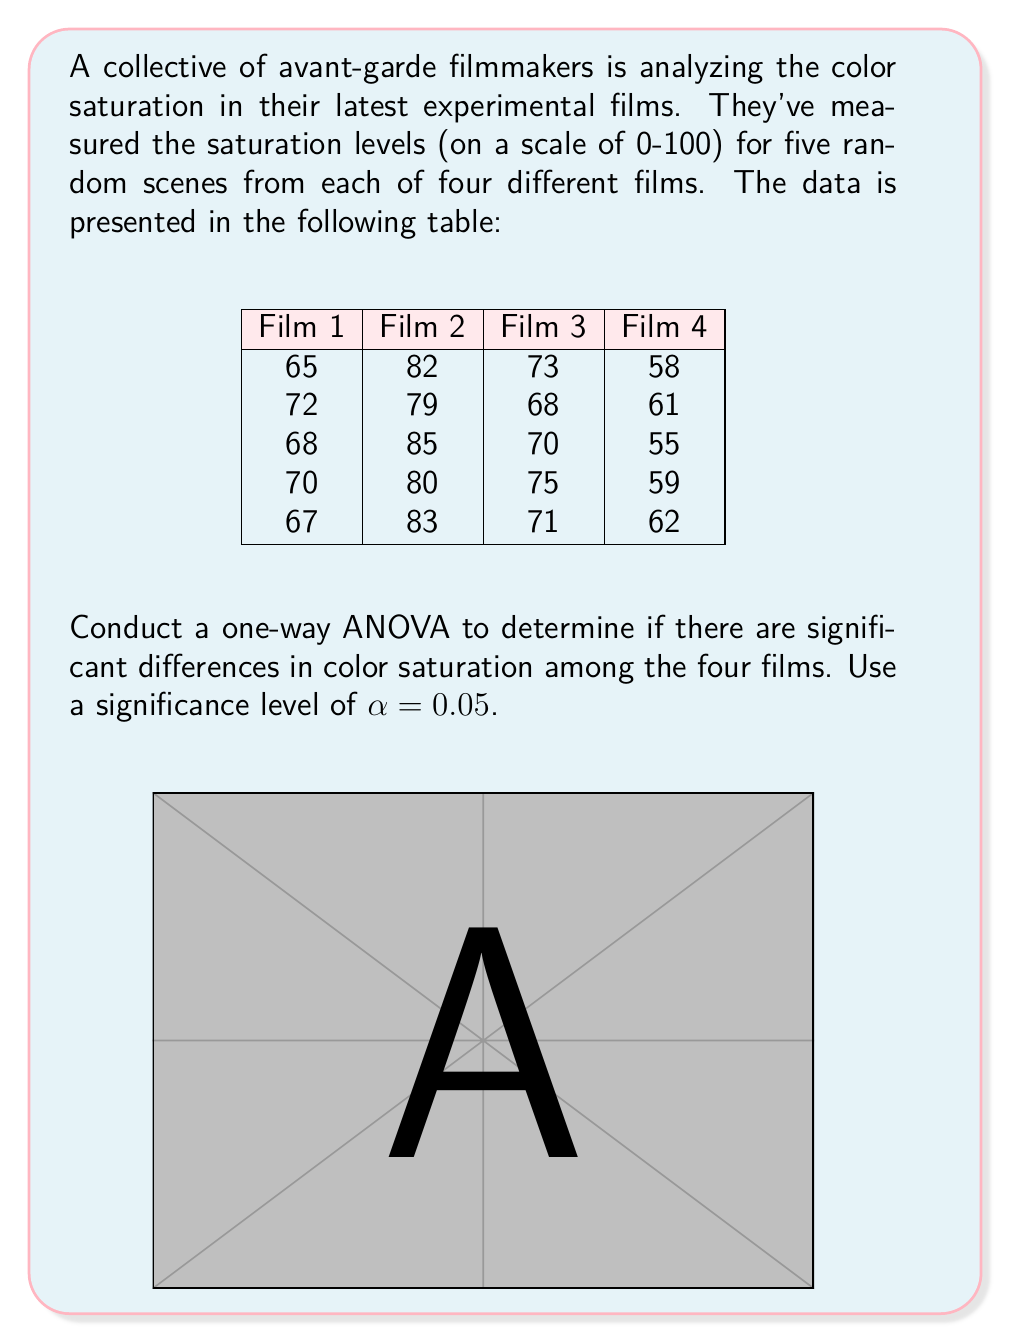Give your solution to this math problem. Let's conduct a one-way ANOVA step by step:

1) First, we need to calculate the following:
   - Grand mean
   - Sum of squares total (SST)
   - Sum of squares between groups (SSB)
   - Sum of squares within groups (SSW)
   - Degrees of freedom
   - Mean square between groups (MSB)
   - Mean square within groups (MSW)
   - F-statistic

2) Calculate the grand mean:
   $\bar{X} = \frac{65+72+68+70+67+82+79+85+80+83+73+68+70+75+71+58+61+55+59+62}{20} = 71.15$

3) Calculate SST:
   $SST = \sum_{i=1}^{4}\sum_{j=1}^{5} (X_{ij} - \bar{X})^2 = 1842.55$

4) Calculate SSB:
   $SSB = 5[(68.4-71.15)^2 + (81.8-71.15)^2 + (71.4-71.15)^2 + (59-71.15)^2] = 1537.55$

5) Calculate SSW:
   $SSW = SST - SSB = 1842.55 - 1537.55 = 305$

6) Degrees of freedom:
   - Between groups: $df_B = 4 - 1 = 3$
   - Within groups: $df_W = 20 - 4 = 16$
   - Total: $df_T = 20 - 1 = 19$

7) Calculate MSB and MSW:
   $MSB = \frac{SSB}{df_B} = \frac{1537.55}{3} = 512.52$
   $MSW = \frac{SSW}{df_W} = \frac{305}{16} = 19.06$

8) Calculate F-statistic:
   $F = \frac{MSB}{MSW} = \frac{512.52}{19.06} = 26.89$

9) Find the critical F-value:
   For α = 0.05, df_B = 3, and df_W = 16, the critical F-value is approximately 3.24.

10) Decision:
    Since the calculated F-value (26.89) is greater than the critical F-value (3.24), we reject the null hypothesis.
Answer: $F(3,16) = 26.89, p < 0.05$. Significant differences exist in color saturation among the four films. 